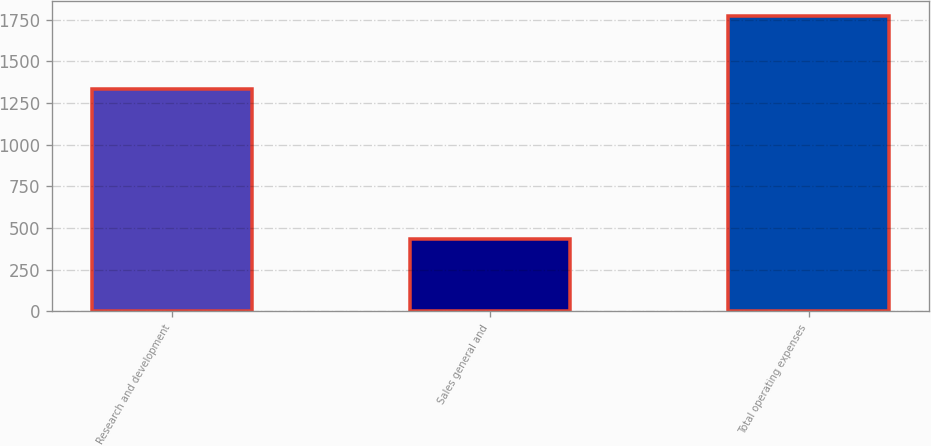Convert chart to OTSL. <chart><loc_0><loc_0><loc_500><loc_500><bar_chart><fcel>Research and development<fcel>Sales general and<fcel>Total operating expenses<nl><fcel>1335.8<fcel>435.7<fcel>1771.5<nl></chart> 